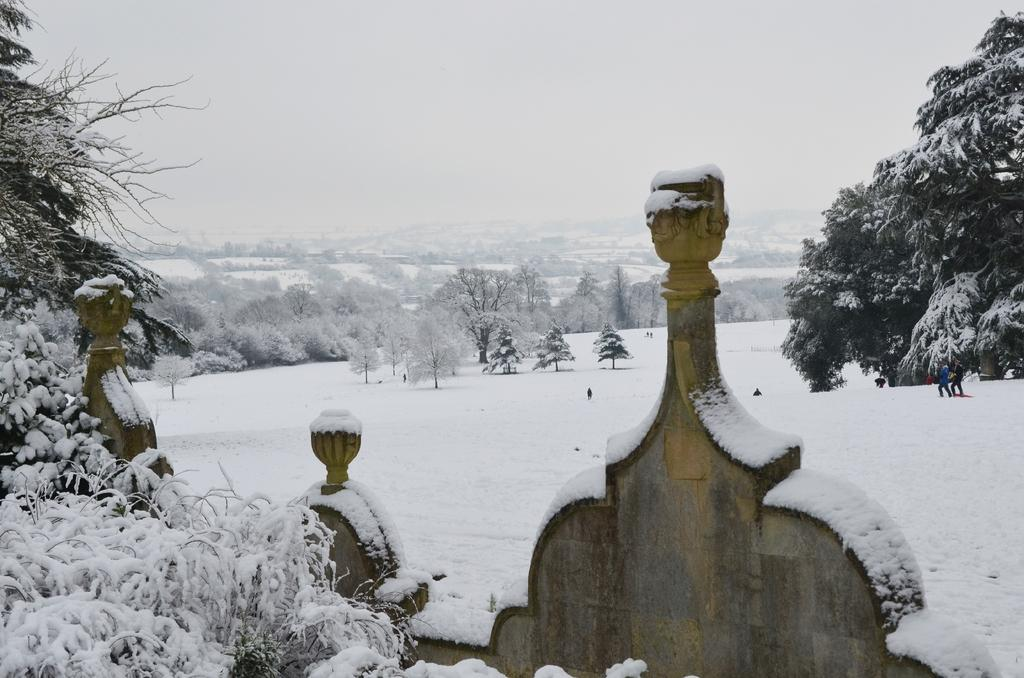What is the main subject of the image? The image appears to depict a wall. Can you describe the setting behind the wall? There are two people on the snow behind the wall, and trees are visible behind them. What can be seen in the distance behind the trees? There are hills in the background. What is visible in the sky in the image? The sky is visible in the background. What type of business is being conducted by the kitty in the image? There is no kitty present in the image, and therefore no business can be conducted by a kitty. 